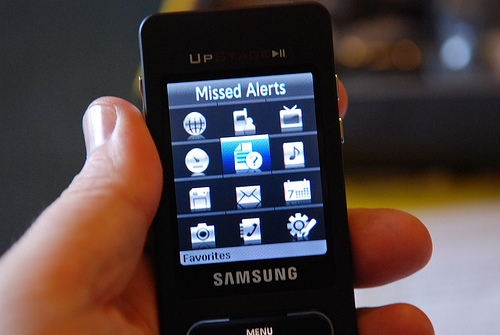How many phones are in the photo? 1 